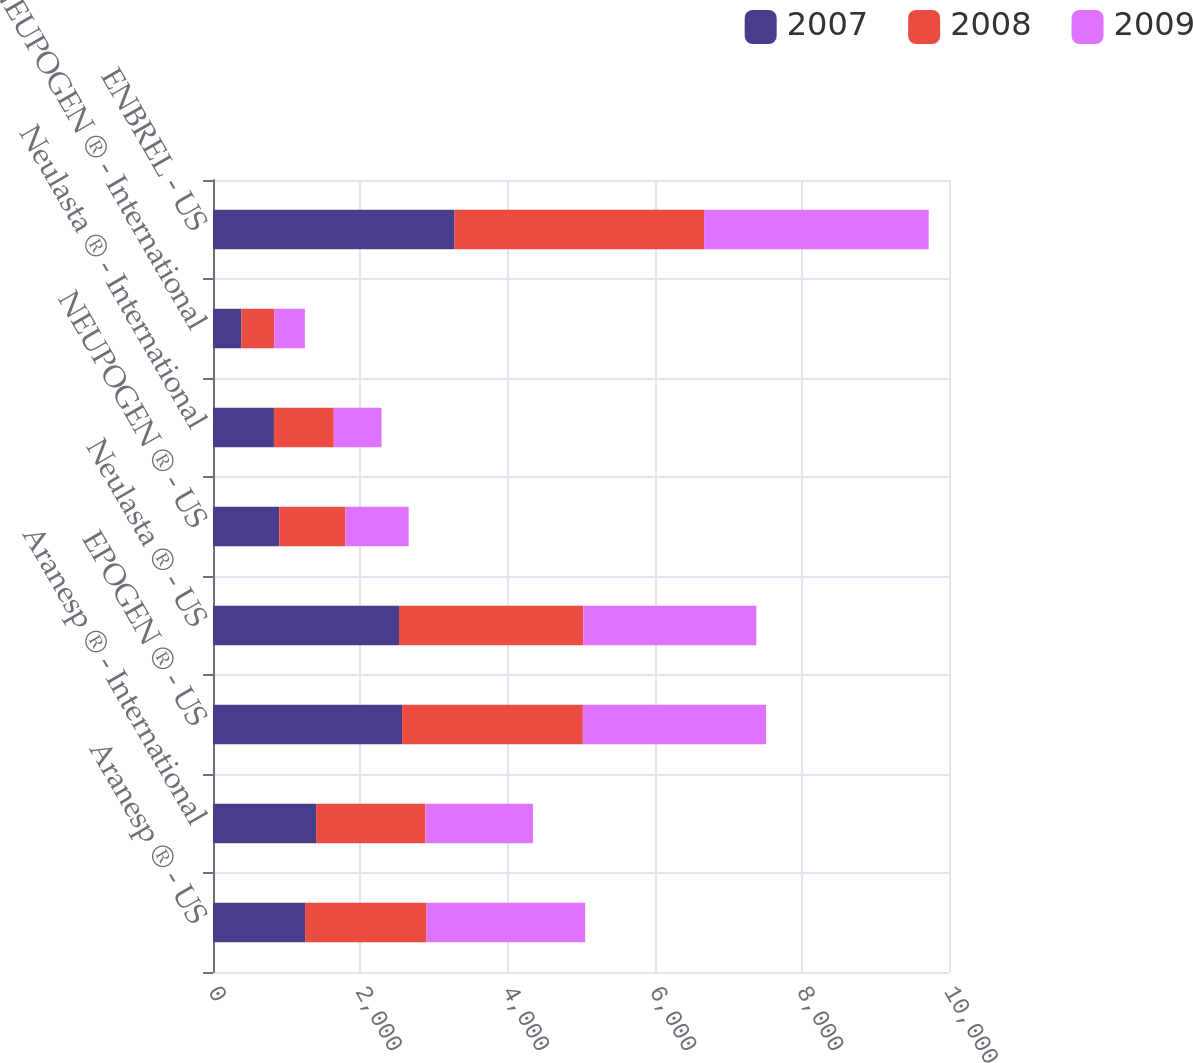Convert chart to OTSL. <chart><loc_0><loc_0><loc_500><loc_500><stacked_bar_chart><ecel><fcel>Aranesp ® - US<fcel>Aranesp ® - International<fcel>EPOGEN ® - US<fcel>Neulasta ® - US<fcel>NEUPOGEN ® - US<fcel>Neulasta ® - International<fcel>NEUPOGEN ® - International<fcel>ENBREL - US<nl><fcel>2007<fcel>1251<fcel>1401<fcel>2569<fcel>2527<fcel>901<fcel>828<fcel>387<fcel>3283<nl><fcel>2008<fcel>1651<fcel>1486<fcel>2456<fcel>2505<fcel>896<fcel>813<fcel>445<fcel>3389<nl><fcel>2009<fcel>2154<fcel>1460<fcel>2489<fcel>2351<fcel>861<fcel>649<fcel>416<fcel>3052<nl></chart> 